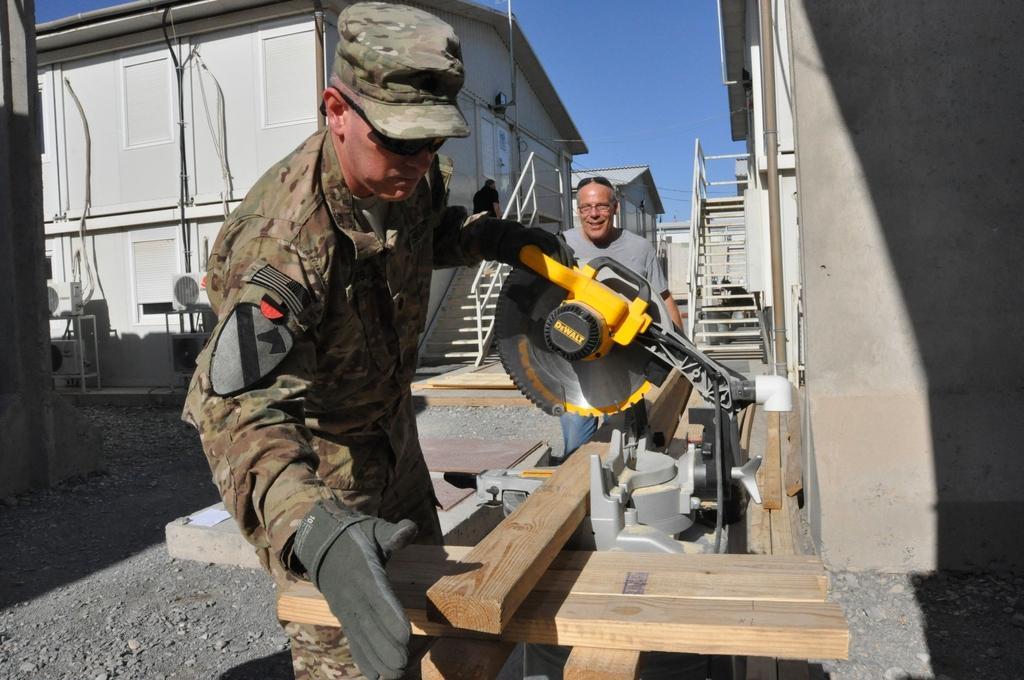Describe this image in one or two sentences. In this image, we can see people and one of them is wearing uniform, cap, glasses and gloves and holding a machine. In the background, there are stairs and we can see sheds, pipes and there is wood. At the bottom, there is ground and at the top, there is sky. 